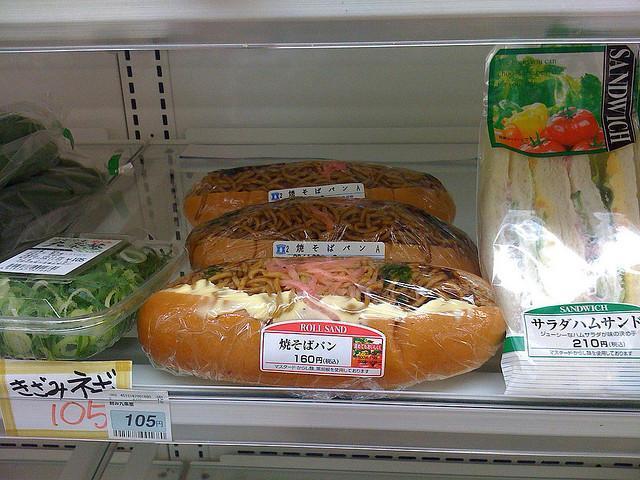How many sandwiches do you see?
Give a very brief answer. 3. How many sandwiches are there?
Give a very brief answer. 4. 